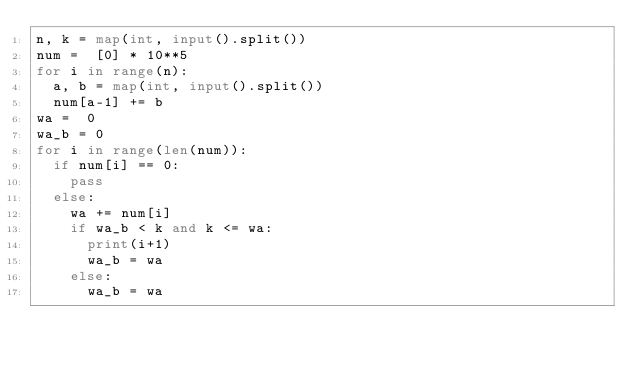Convert code to text. <code><loc_0><loc_0><loc_500><loc_500><_Python_>n, k = map(int, input().split())
num =  [0] * 10**5
for i in range(n):
  a, b = map(int, input().split())
  num[a-1] += b
wa =  0
wa_b = 0
for i in range(len(num)):
  if num[i] == 0:
    pass
  else:
    wa += num[i]
    if wa_b < k and k <= wa:
      print(i+1)
      wa_b = wa
    else:
      wa_b = wa</code> 